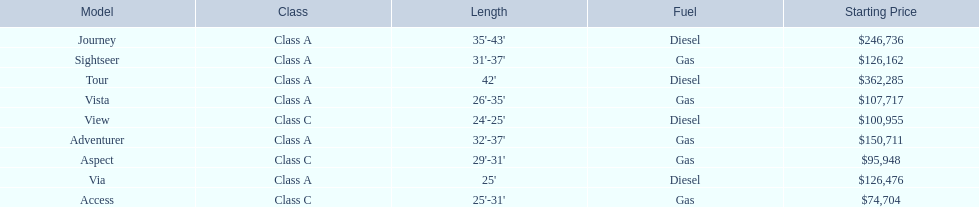Which models of winnebago are there? Tour, Journey, Adventurer, Via, Sightseer, Vista, View, Aspect, Access. Which ones are diesel? Tour, Journey, Sightseer, View. Which of those is the longest? Tour, Journey. Which one has the highest starting price? Tour. 